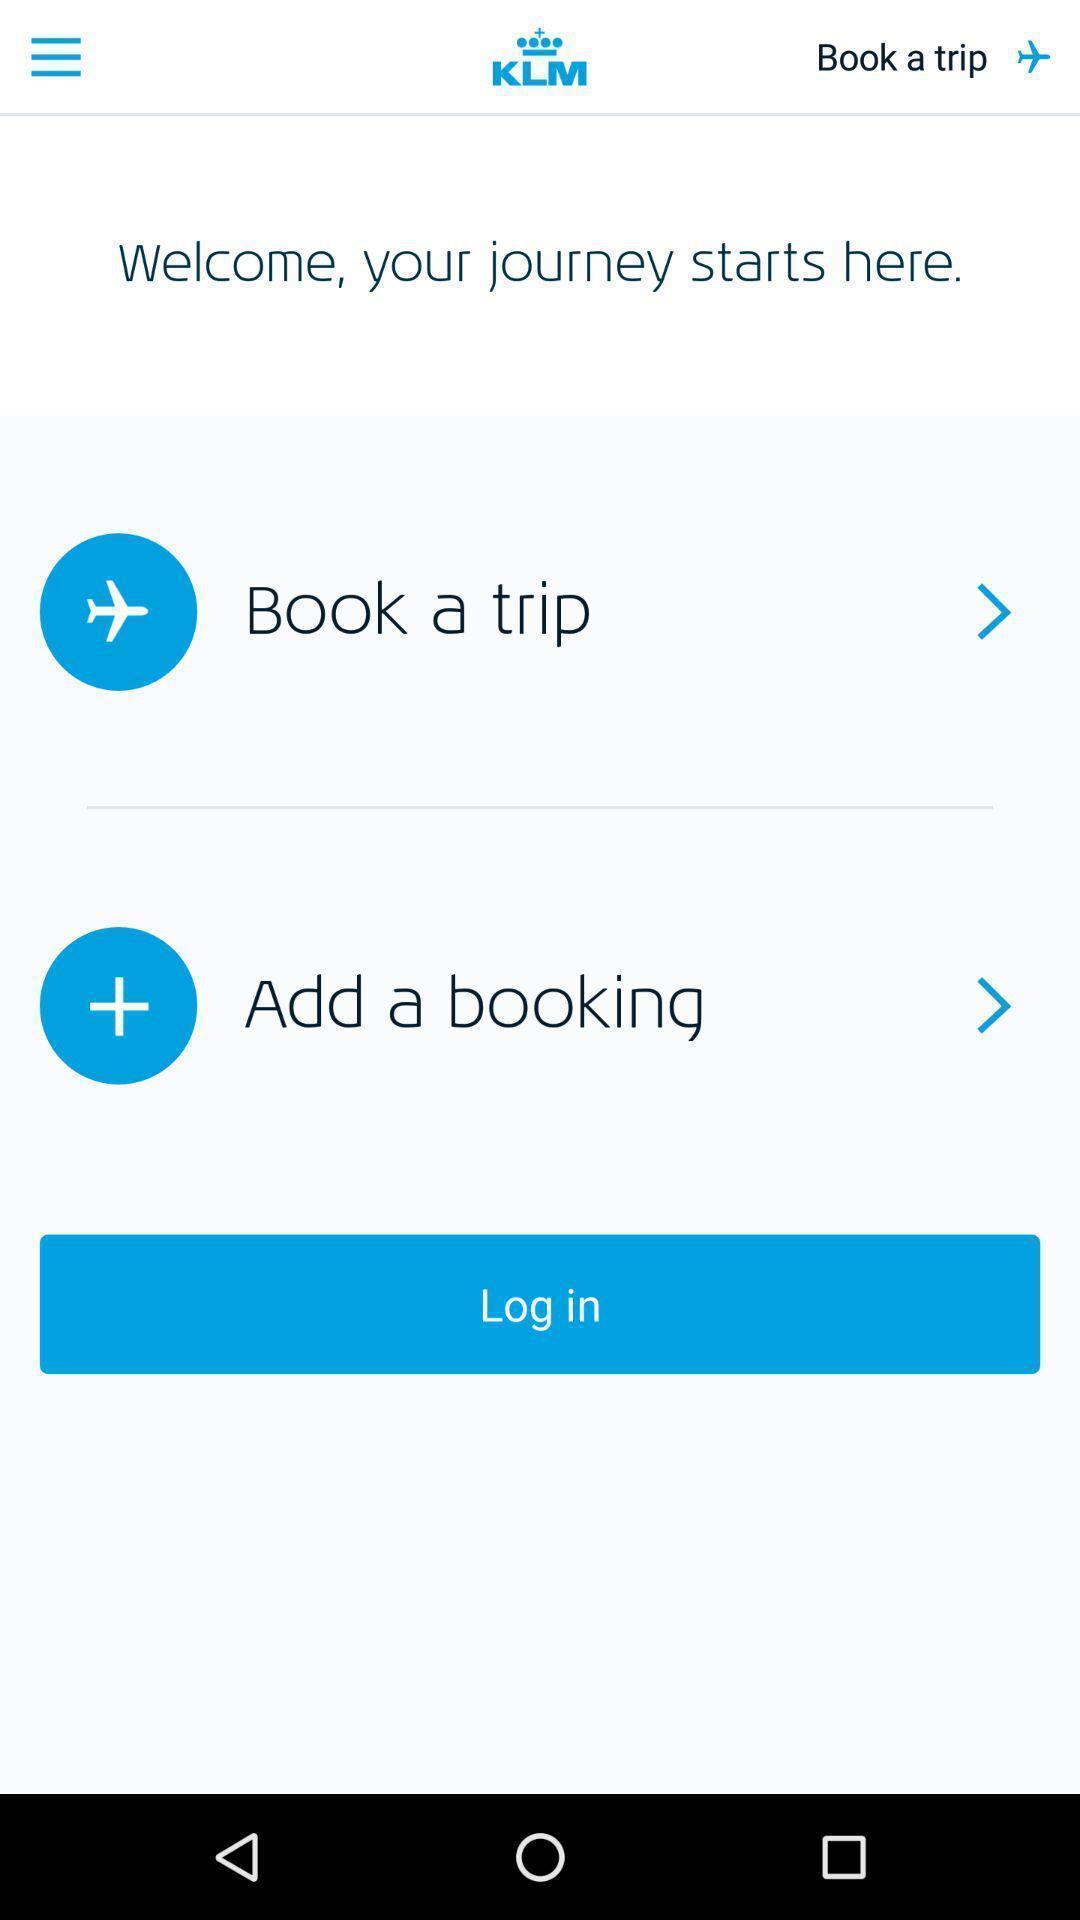Please provide a description for this image. Welcome page. 